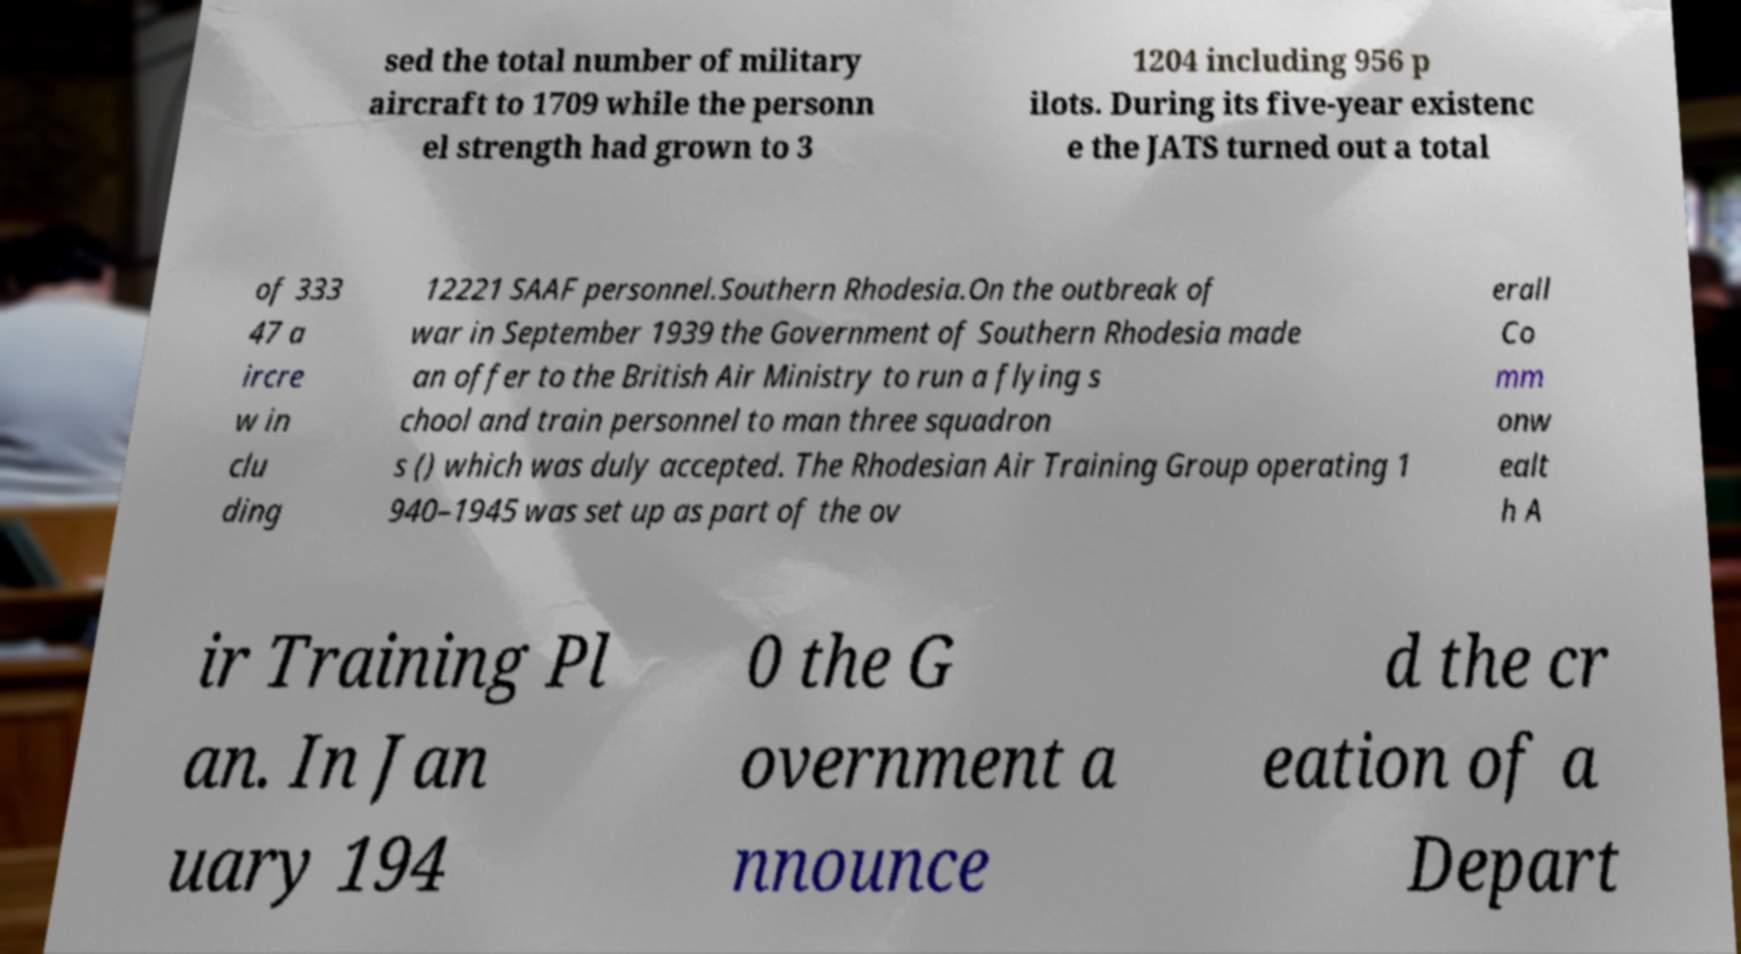There's text embedded in this image that I need extracted. Can you transcribe it verbatim? sed the total number of military aircraft to 1709 while the personn el strength had grown to 3 1204 including 956 p ilots. During its five-year existenc e the JATS turned out a total of 333 47 a ircre w in clu ding 12221 SAAF personnel.Southern Rhodesia.On the outbreak of war in September 1939 the Government of Southern Rhodesia made an offer to the British Air Ministry to run a flying s chool and train personnel to man three squadron s () which was duly accepted. The Rhodesian Air Training Group operating 1 940–1945 was set up as part of the ov erall Co mm onw ealt h A ir Training Pl an. In Jan uary 194 0 the G overnment a nnounce d the cr eation of a Depart 